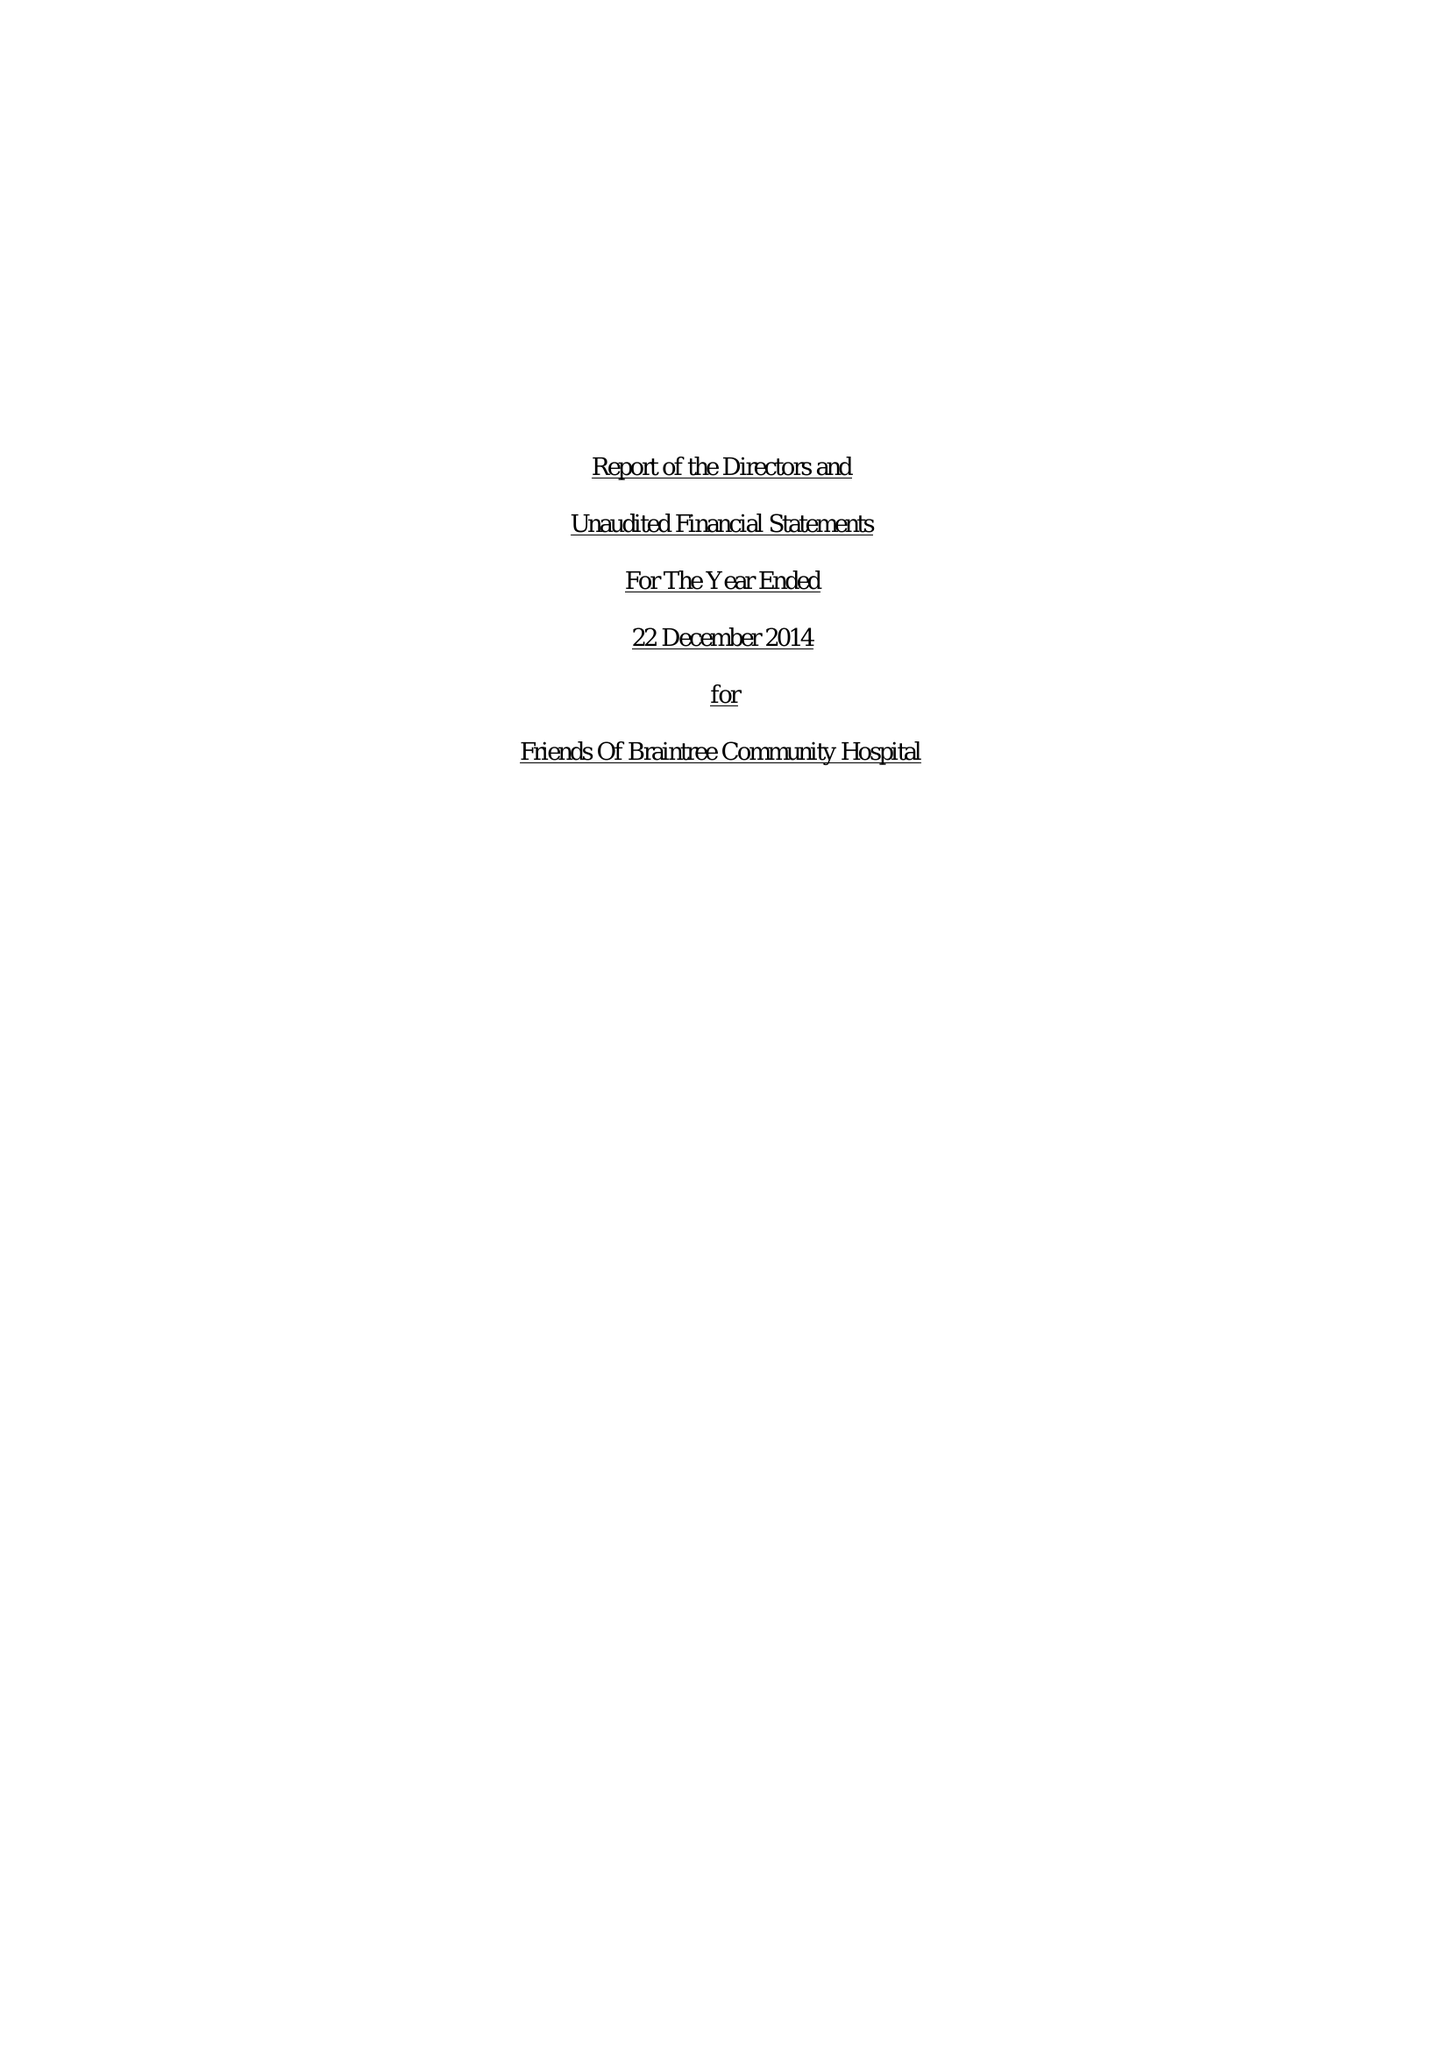What is the value for the charity_name?
Answer the question using a single word or phrase. Friends Of Braintree Community Hospital 